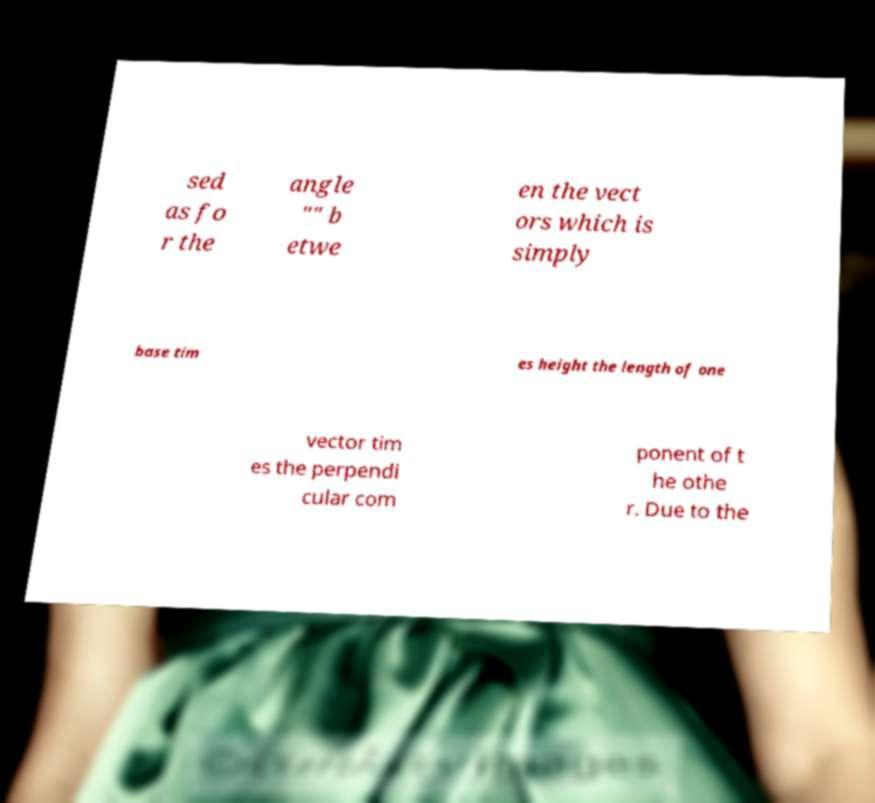There's text embedded in this image that I need extracted. Can you transcribe it verbatim? sed as fo r the angle "" b etwe en the vect ors which is simply base tim es height the length of one vector tim es the perpendi cular com ponent of t he othe r. Due to the 